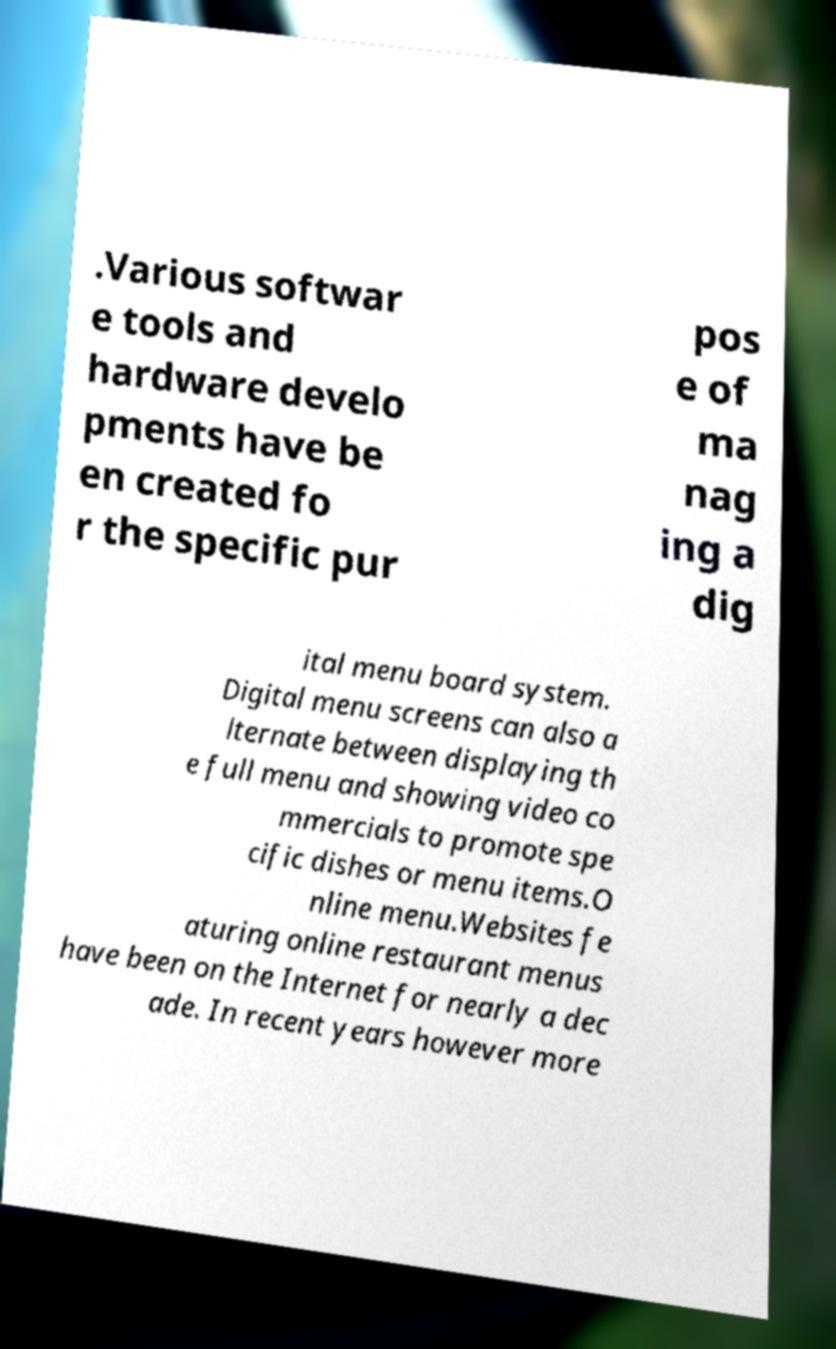For documentation purposes, I need the text within this image transcribed. Could you provide that? .Various softwar e tools and hardware develo pments have be en created fo r the specific pur pos e of ma nag ing a dig ital menu board system. Digital menu screens can also a lternate between displaying th e full menu and showing video co mmercials to promote spe cific dishes or menu items.O nline menu.Websites fe aturing online restaurant menus have been on the Internet for nearly a dec ade. In recent years however more 